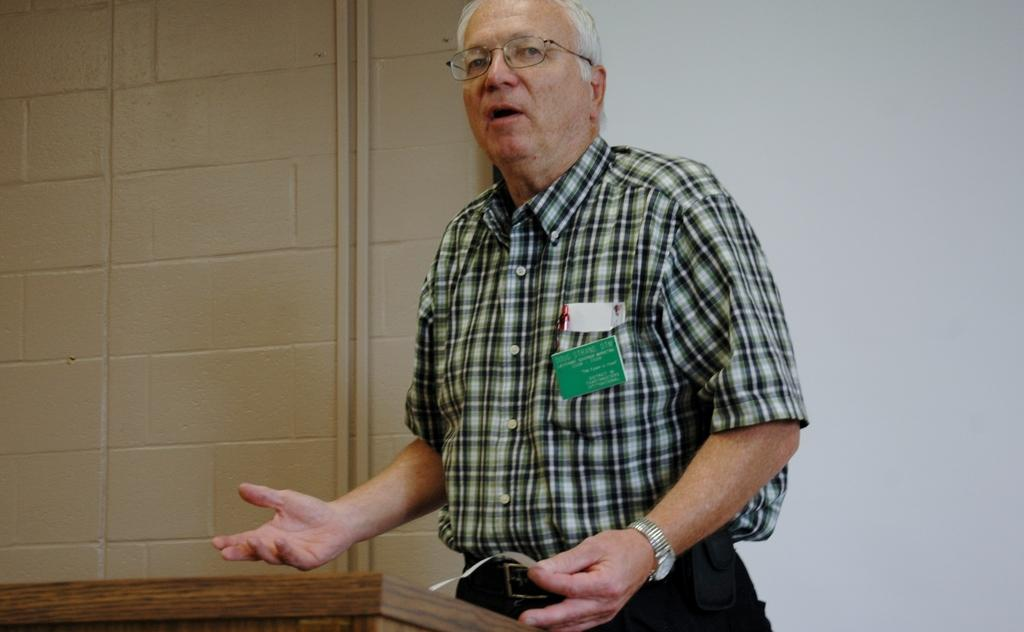Who is the main subject in the image? There is a person in the center of the image. What is the person doing in the image? The person is talking. What is the person holding in the image? The person is holding a paper. What is in front of the person in the image? There is a podium in front of the person. What can be seen in the background of the image? There is a wall and a board in the background of the image. Can you hear the bell ringing in the image? There is no bell present in the image, so it cannot be heard. 